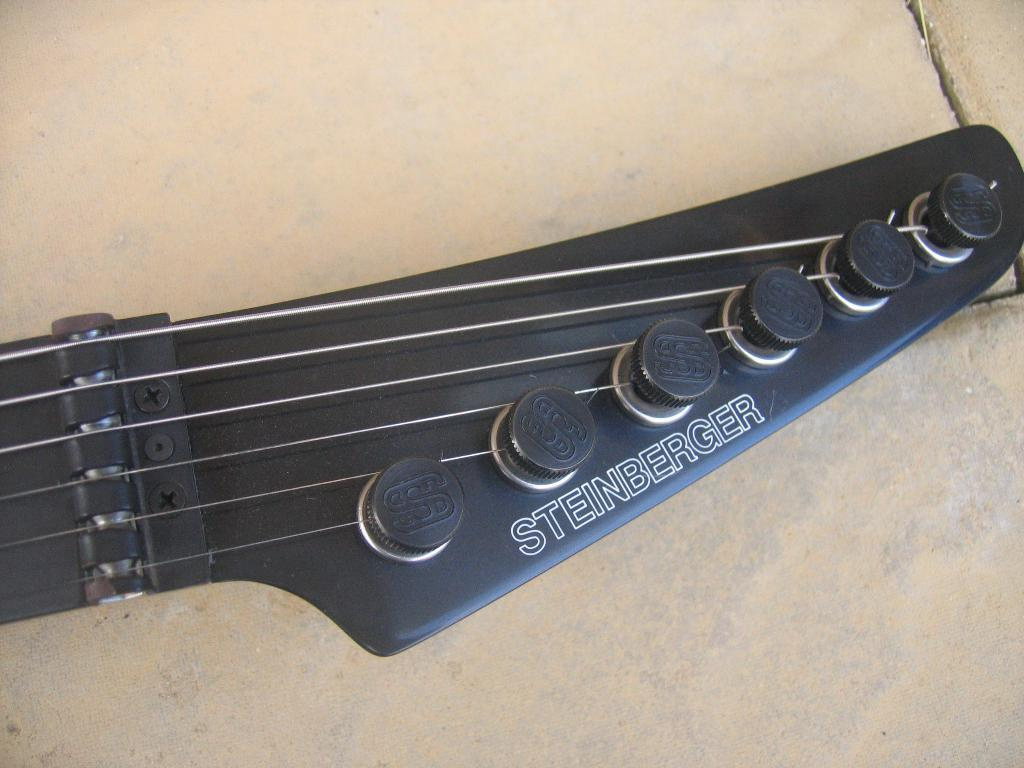What musical instrument is present in the image? There is a guitar in the image. What color is the guitar? The guitar is black in color. How many strings does the guitar have? The guitar has six strings. Where is the guitar located in the image? The guitar is on the floor. Is the guitar sinking in quicksand in the image? No, the guitar is not sinking in quicksand in the image; it is on the floor. 